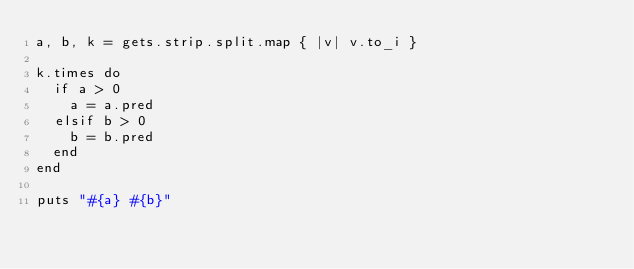Convert code to text. <code><loc_0><loc_0><loc_500><loc_500><_Ruby_>a, b, k = gets.strip.split.map { |v| v.to_i }

k.times do
  if a > 0
    a = a.pred
  elsif b > 0
    b = b.pred
  end
end

puts "#{a} #{b}"
</code> 